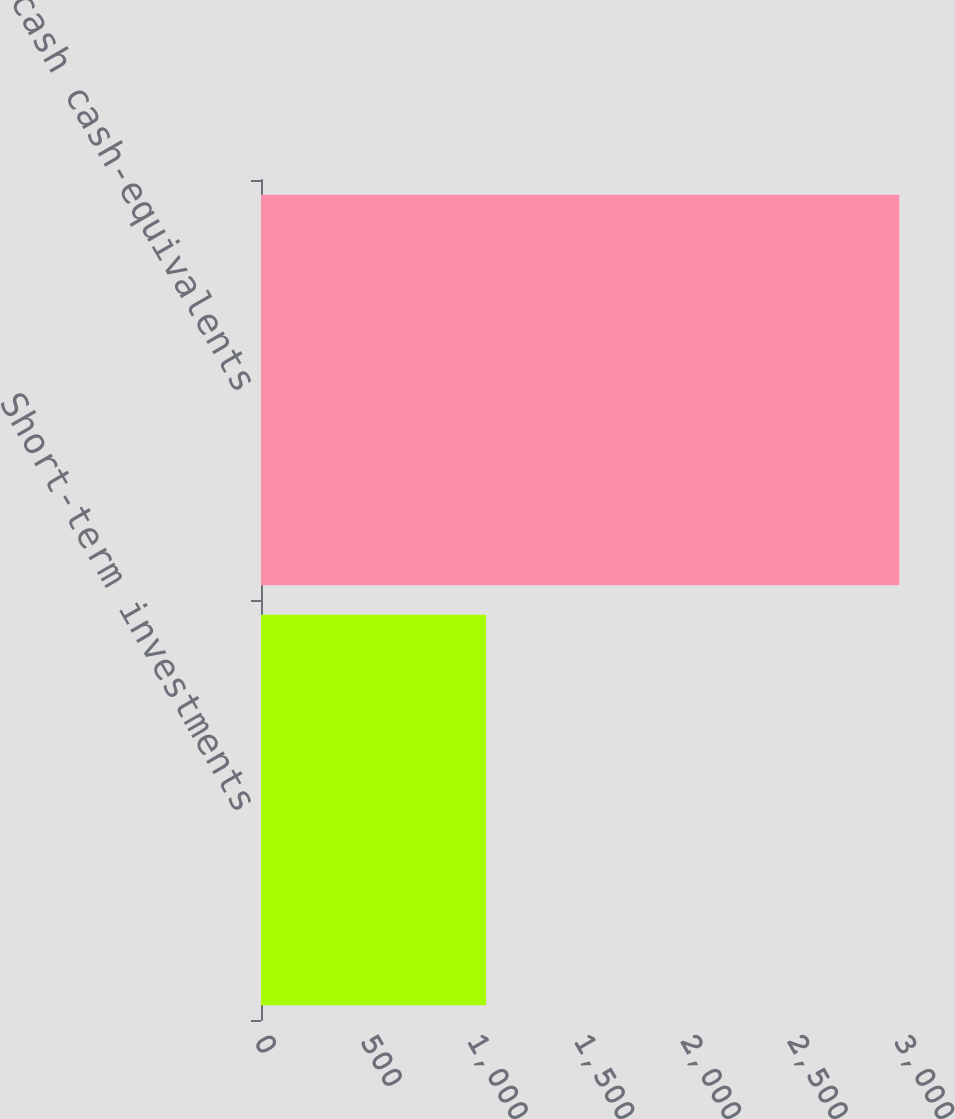Convert chart. <chart><loc_0><loc_0><loc_500><loc_500><bar_chart><fcel>Short-term investments<fcel>Total cash cash-equivalents<nl><fcel>1055<fcel>2992<nl></chart> 